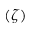<formula> <loc_0><loc_0><loc_500><loc_500>( \zeta )</formula> 